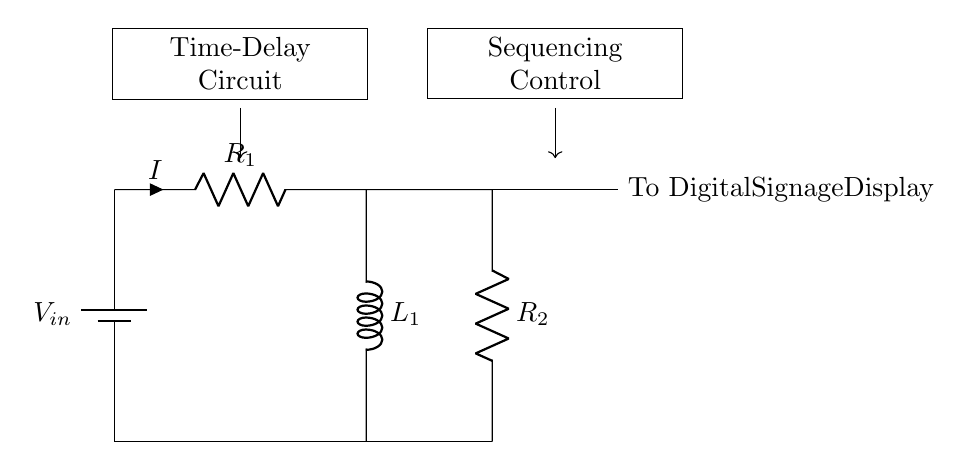What is the input voltage for this circuit? The input voltage is indicated by the battery symbol in the diagram, represented as V_in.
Answer: V_in What components are present in the circuit? The circuit consists of a battery, a resistor (R1), an inductor (L1), and another resistor (R2).
Answer: Battery, R1, L1, R2 How many resistors are in the circuit? There are two resistors shown in the circuit diagram: R1 and R2.
Answer: 2 What is the current direction in the circuit? The current direction is shown by the arrow on the same wire connected to resistor R1, indicating that current I flows from the battery through R1 to L1.
Answer: Downwards What happens to the current over time due to the inductor? The inductor L1 will cause the current to grow gradually, creating a time delay in reaching its maximum value.
Answer: Current grows gradually How is the sequence of the digital signage display controlled? The sequence control is indicated by the connection point labeled 'To Digital Signage Display,' which signifies how the circuit operates in a timed manner for activating signage.
Answer: Timed manner What role does resistor R2 play in the circuit? Resistor R2 is part of the output section that likely helps in further controlling the output current flowing to the digital signage display.
Answer: Output current control 